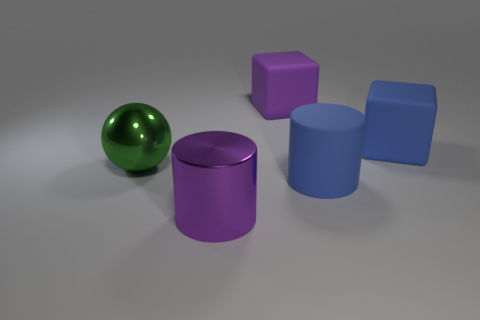Is the color of the thing on the right side of the blue rubber cylinder the same as the big cylinder that is right of the large purple metallic cylinder?
Make the answer very short. Yes. Are there any other things of the same color as the rubber cylinder?
Your answer should be very brief. Yes. Are any yellow things visible?
Provide a short and direct response. No. Are there any large blue objects in front of the blue cylinder?
Your answer should be very brief. No. There is a large blue object that is the same shape as the big purple shiny object; what is its material?
Give a very brief answer. Rubber. What number of other objects are the same shape as the large purple matte thing?
Offer a very short reply. 1. There is a block that is to the left of the big blue matte object behind the green thing; how many purple shiny objects are right of it?
Your answer should be very brief. 0. What number of large matte things have the same shape as the purple metal object?
Give a very brief answer. 1. There is a big rubber object that is right of the rubber cylinder; does it have the same color as the rubber cylinder?
Your answer should be compact. Yes. There is a big metallic thing that is behind the large shiny object in front of the large blue matte thing that is on the left side of the blue rubber cube; what shape is it?
Give a very brief answer. Sphere. 